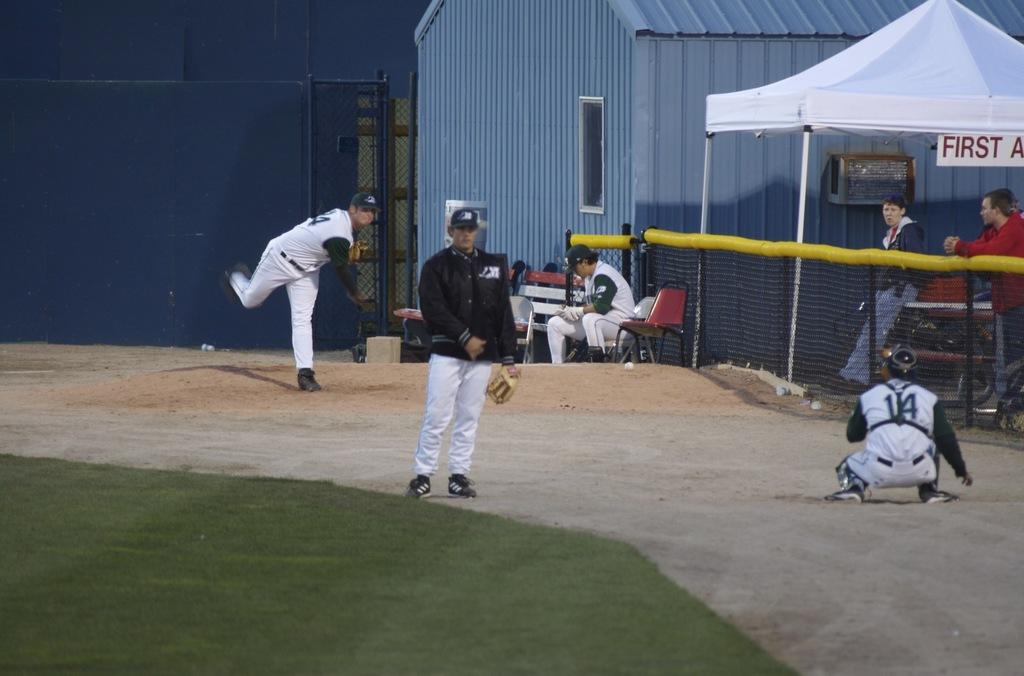<image>
Describe the image concisely. First aid tent set up next to a baseball field where players are practicing. 